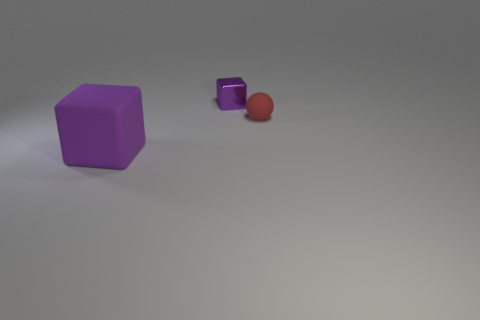Add 2 cyan objects. How many objects exist? 5 Subtract all balls. How many objects are left? 2 Subtract 0 green cylinders. How many objects are left? 3 Subtract all gray shiny objects. Subtract all large purple blocks. How many objects are left? 2 Add 1 small red objects. How many small red objects are left? 2 Add 1 tiny objects. How many tiny objects exist? 3 